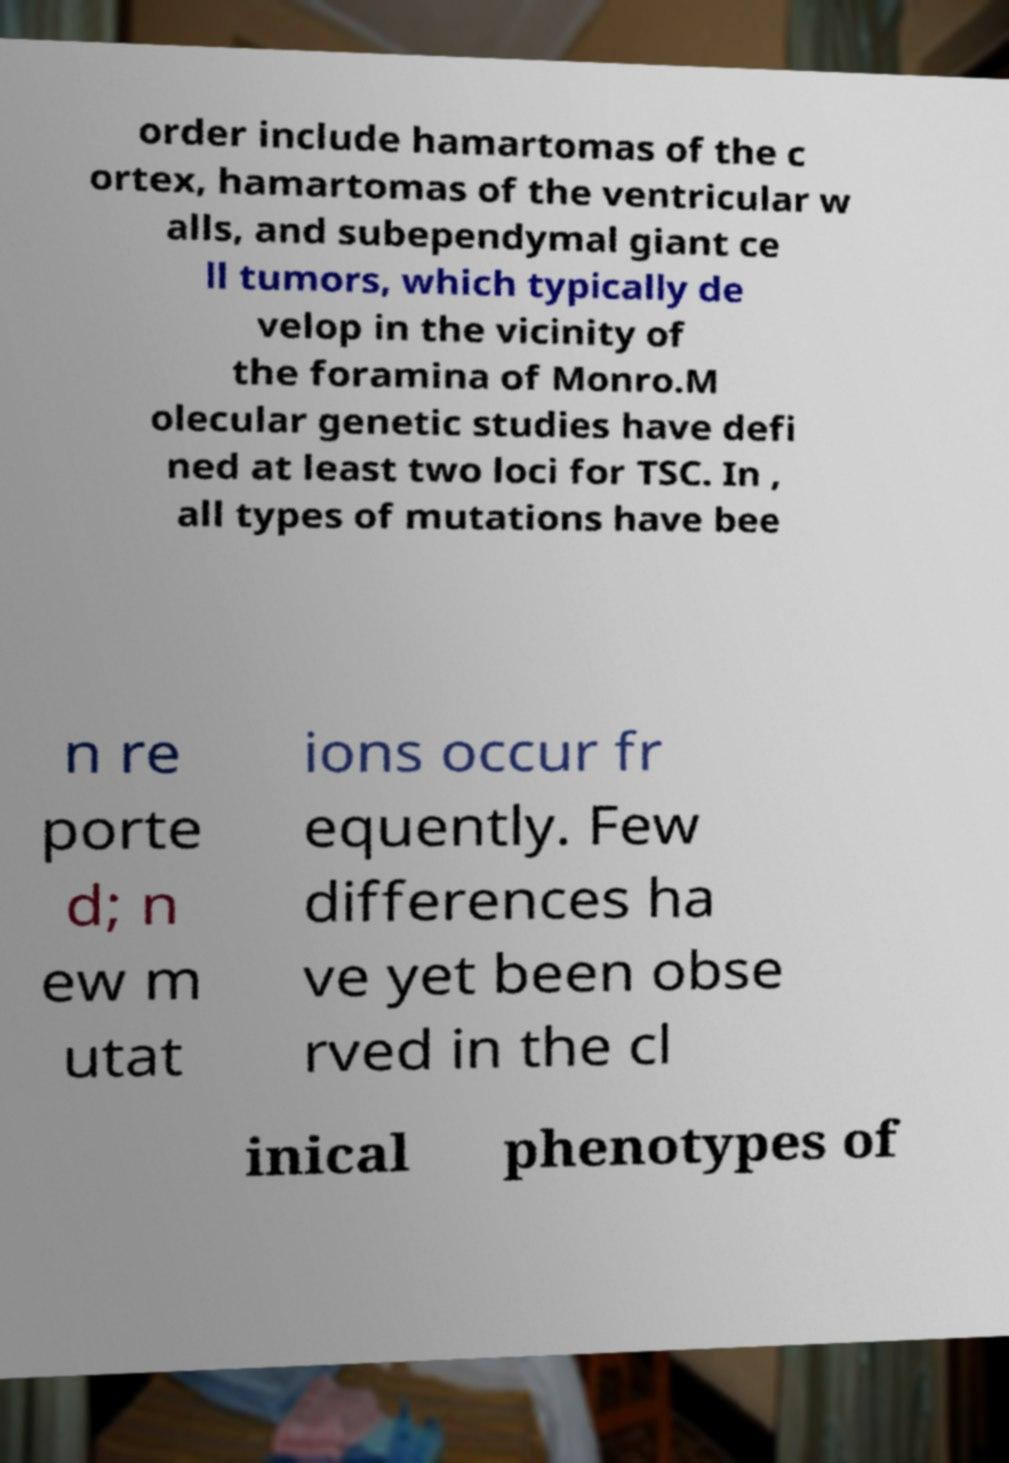I need the written content from this picture converted into text. Can you do that? order include hamartomas of the c ortex, hamartomas of the ventricular w alls, and subependymal giant ce ll tumors, which typically de velop in the vicinity of the foramina of Monro.M olecular genetic studies have defi ned at least two loci for TSC. In , all types of mutations have bee n re porte d; n ew m utat ions occur fr equently. Few differences ha ve yet been obse rved in the cl inical phenotypes of 